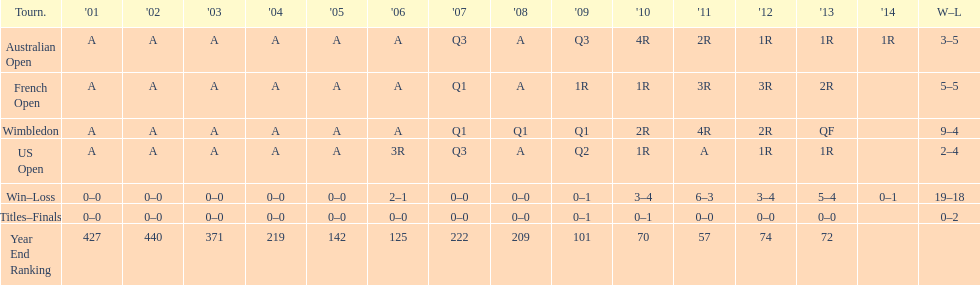What tournament has 5-5 as it's "w-l" record? French Open. 